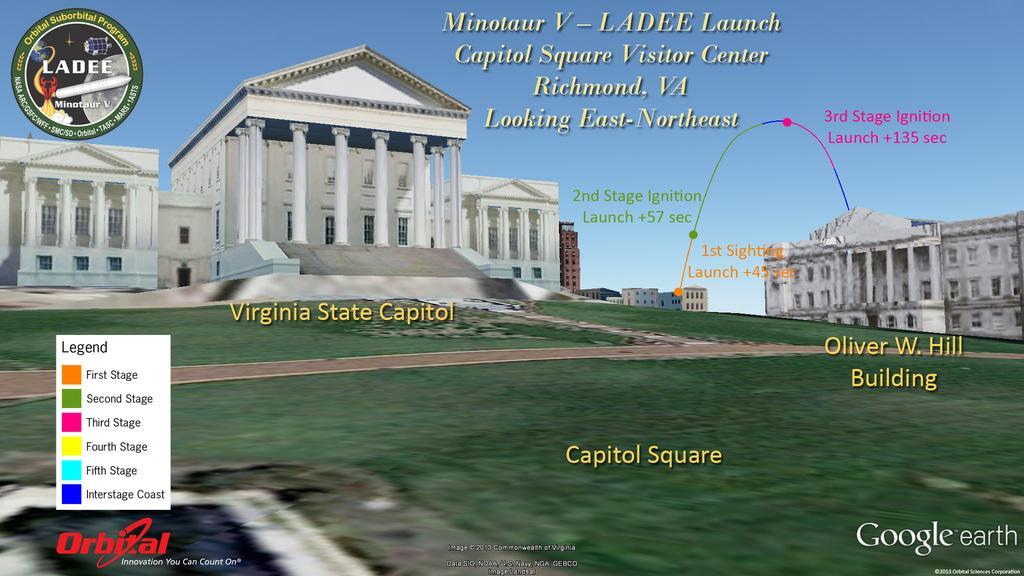Can you describe this image briefly? In this image I can see the ground and many buildings. In the background I can see the blue sky. I can see something is written on the image. 